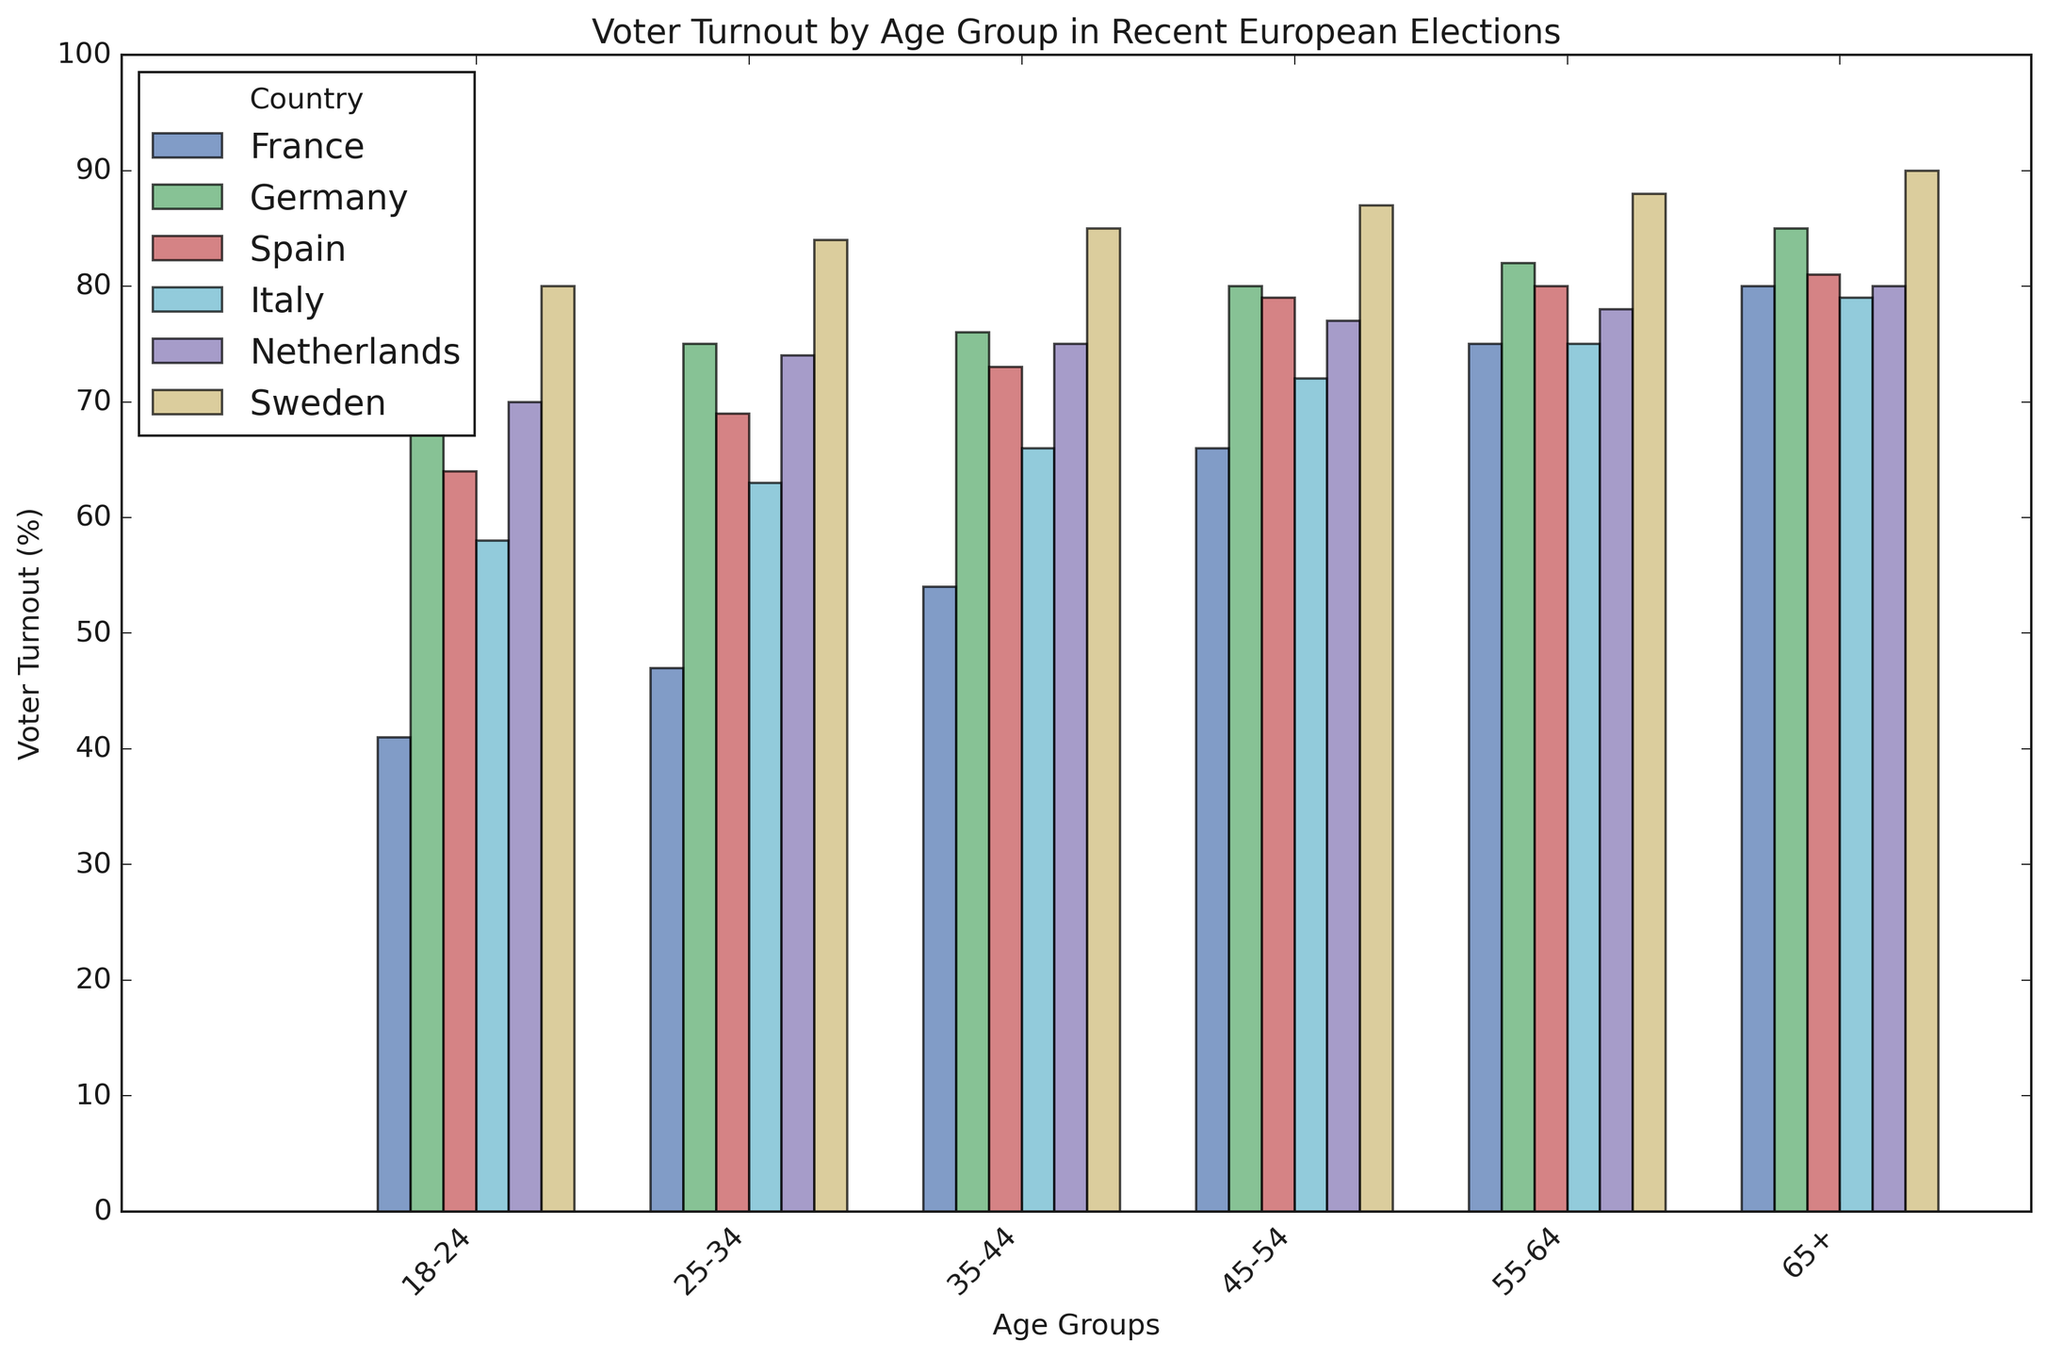What is the voter turnout for the 18-24 age group in Sweden? Identify the bar for the 18-24 age group and the country Sweden. The height of this bar represents the voter turnout. It shows 80%.
Answer: 80% Which country has the highest voter turnout in the 65+ age group? Compare the height of the bars for the 65+ age group across all countries. Sweden has the tallest bar, indicating the highest voter turnout at 90%.
Answer: Sweden Compare the voter turnout between the 25-34 and 55-64 age groups in Italy. Which age group has a higher turnout and by how much? Subtract the voter turnout value of the 25-34 age group from that of the 55-64 age group in Italy. 75% (55-64) - 63% (25-34) = 12%. The 55-64 age group has a higher turnout by 12 percentage points.
Answer: 55-64 age group, 12% What is the average voter turnout for the 35-44 age group across all countries? Sum the voter turnout values for the 35-44 age group across France, Germany, Spain, Italy, Netherlands, and Sweden, then divide by the number of countries. (54 + 76 + 73 + 66 + 75 + 85) / 6 = 71.5%.
Answer: 71.5% How does the voter turnout for the 45-54 age group in France compare to the same age group in Germany? Subtract the voter turnout of the 45-54 age group in France from that in Germany. 80% (Germany) - 66% (France) = 14%. Germany's turnout is 14 percentage points higher.
Answer: Germany by 14% Which age group in Spain has the lowest voter turnout, and what is the value? Identify the shortest bar among the age groups in Spain. The shortest bar is for the 18-24 age group with a turnout of 64%.
Answer: 18-24, 64% Is there a noticeable trend in voter turnout with increasing age in any country? If so, describe it. Determine the pattern of voter turnouts across age groups for each country. In most countries, voter turnout increases with age, indicating a trend of higher engagement among older age groups.
Answer: Yes, turnout increases with age What is the difference in voter turnout between the youngest (18-24) and oldest (65+) age groups in the Netherlands? Subtract the voter turnout of the 18-24 age group from that of the 65+ age group in the Netherlands. 80% (65+) - 70% (18-24) = 10%.
Answer: 10% Which country has the most consistent voter turnout across different age groups and provide an example of voter turnout values to justify this? Evaluate the differences in voter turnout percentages across all age groups for each country. The Netherlands shows consistency with values being quite close: 70% (18-24), 74% (25-34), 75% (35-44), 77% (45-54), 78% (55-64), 80% (65+). The range is only 10 percentage points.
Answer: Netherlands Compare the voter turnout for 18-24 and 25-34 age groups in France. Which one is higher and by how much? Subtract the voter turnout of the 18-24 age group from that of the 25-34 age group in France. 47% (25-34) - 41% (18-24) = 6%. The 25-34 age group has a higher turnout by 6 percentage points.
Answer: 25-34 age group, 6% 